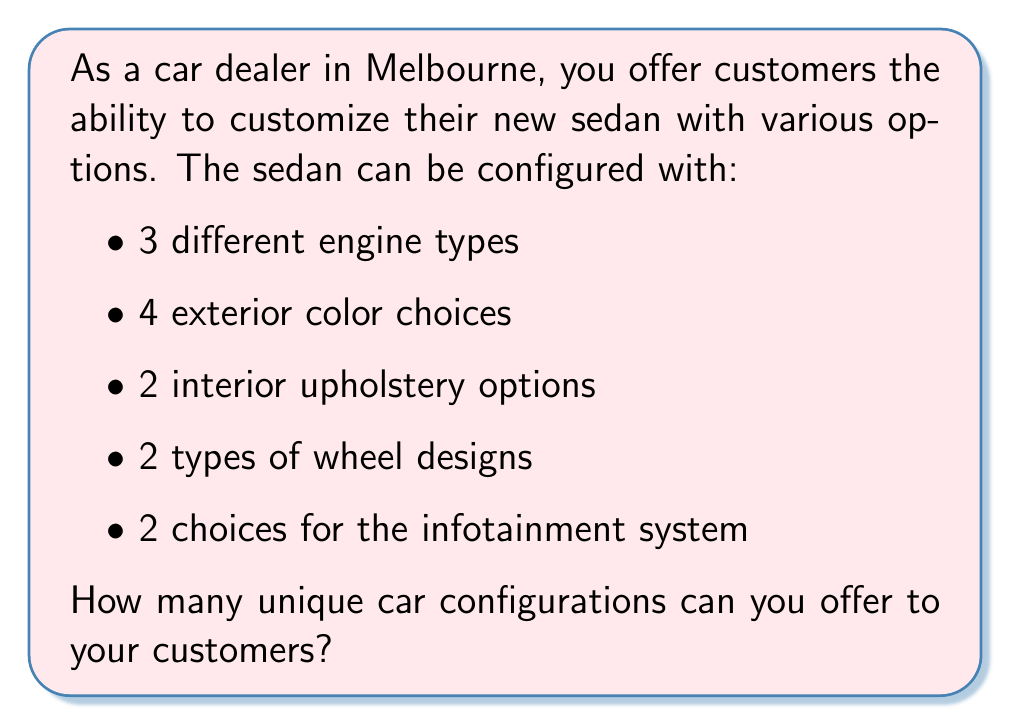Can you solve this math problem? To solve this problem, we need to use the multiplication principle of counting, which is a fundamental concept in permutations and combinations.

1) For each option, we have a certain number of choices:
   - Engine types: 3 choices
   - Exterior colors: 4 choices
   - Interior upholstery: 2 choices
   - Wheel designs: 2 choices
   - Infotainment systems: 2 choices

2) According to the multiplication principle, if we have a series of independent choices, the total number of possible outcomes is the product of the number of possibilities for each choice.

3) Therefore, we can calculate the total number of unique car configurations by multiplying the number of choices for each option:

   $$ \text{Total configurations} = 3 \times 4 \times 2 \times 2 \times 2 $$

4) Let's compute this:
   $$ 3 \times 4 \times 2 \times 2 \times 2 = 96 $$

Thus, the car dealer can offer 96 unique car configurations to customers.

This calculation assumes that all combinations are possible and that choosing one option doesn't restrict the choices for other options.
Answer: 96 unique car configurations 